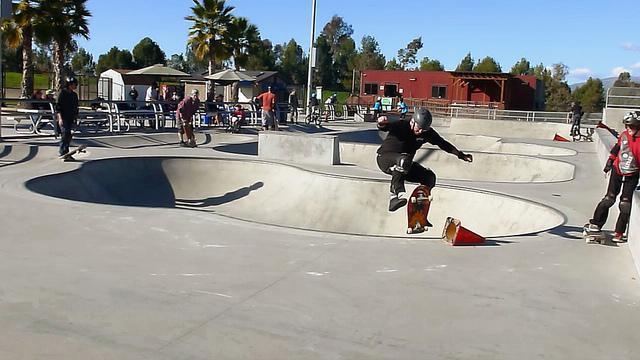How many windows are on the red building in the background?
Give a very brief answer. 3. How many people can be seen?
Give a very brief answer. 3. How many buses are behind a street sign?
Give a very brief answer. 0. 